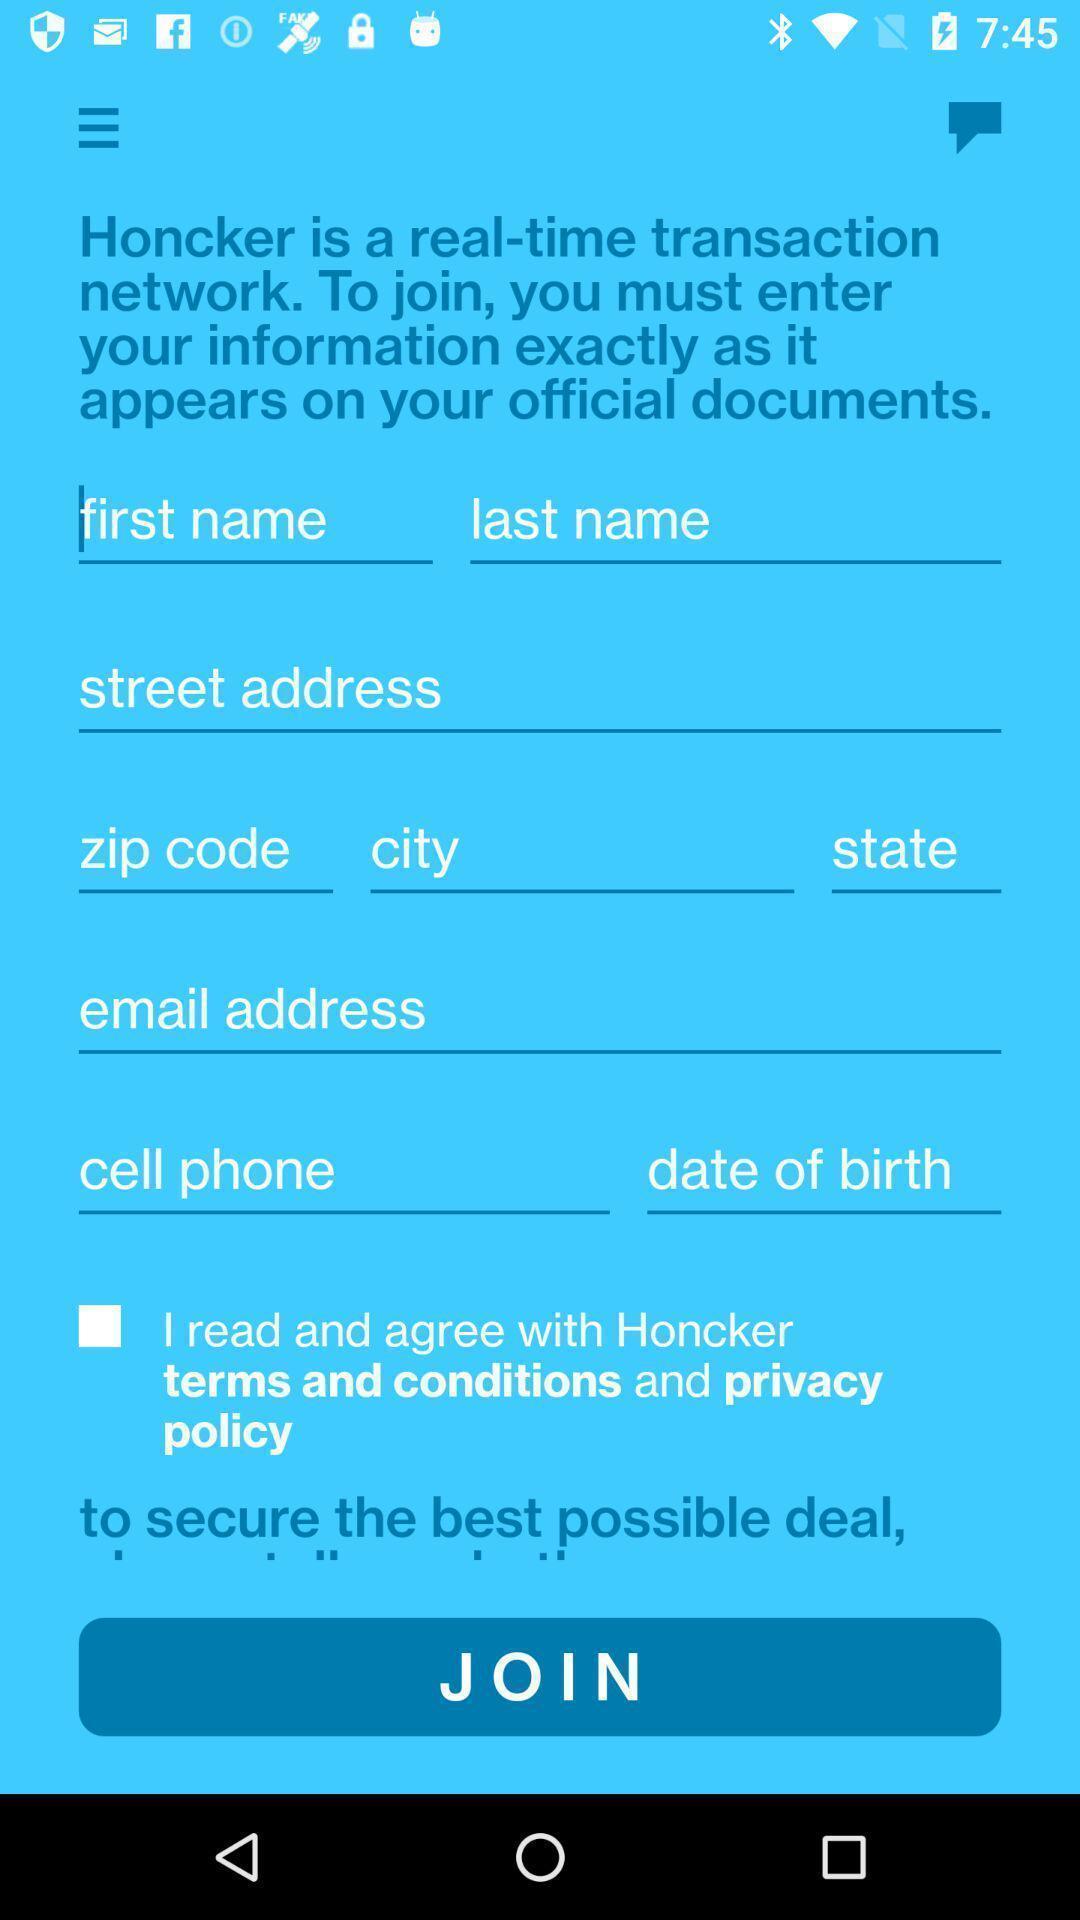Explain what's happening in this screen capture. Starting page. 